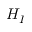<formula> <loc_0><loc_0><loc_500><loc_500>H _ { I }</formula> 